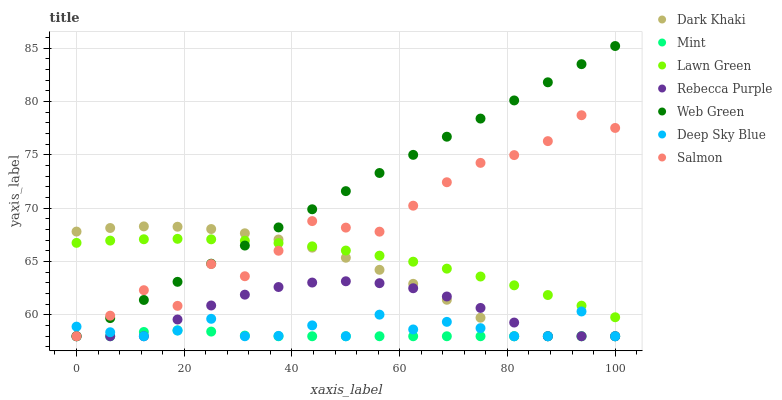Does Mint have the minimum area under the curve?
Answer yes or no. Yes. Does Web Green have the maximum area under the curve?
Answer yes or no. Yes. Does Salmon have the minimum area under the curve?
Answer yes or no. No. Does Salmon have the maximum area under the curve?
Answer yes or no. No. Is Web Green the smoothest?
Answer yes or no. Yes. Is Salmon the roughest?
Answer yes or no. Yes. Is Salmon the smoothest?
Answer yes or no. No. Is Web Green the roughest?
Answer yes or no. No. Does Salmon have the lowest value?
Answer yes or no. Yes. Does Web Green have the highest value?
Answer yes or no. Yes. Does Salmon have the highest value?
Answer yes or no. No. Is Mint less than Lawn Green?
Answer yes or no. Yes. Is Lawn Green greater than Rebecca Purple?
Answer yes or no. Yes. Does Lawn Green intersect Web Green?
Answer yes or no. Yes. Is Lawn Green less than Web Green?
Answer yes or no. No. Is Lawn Green greater than Web Green?
Answer yes or no. No. Does Mint intersect Lawn Green?
Answer yes or no. No. 